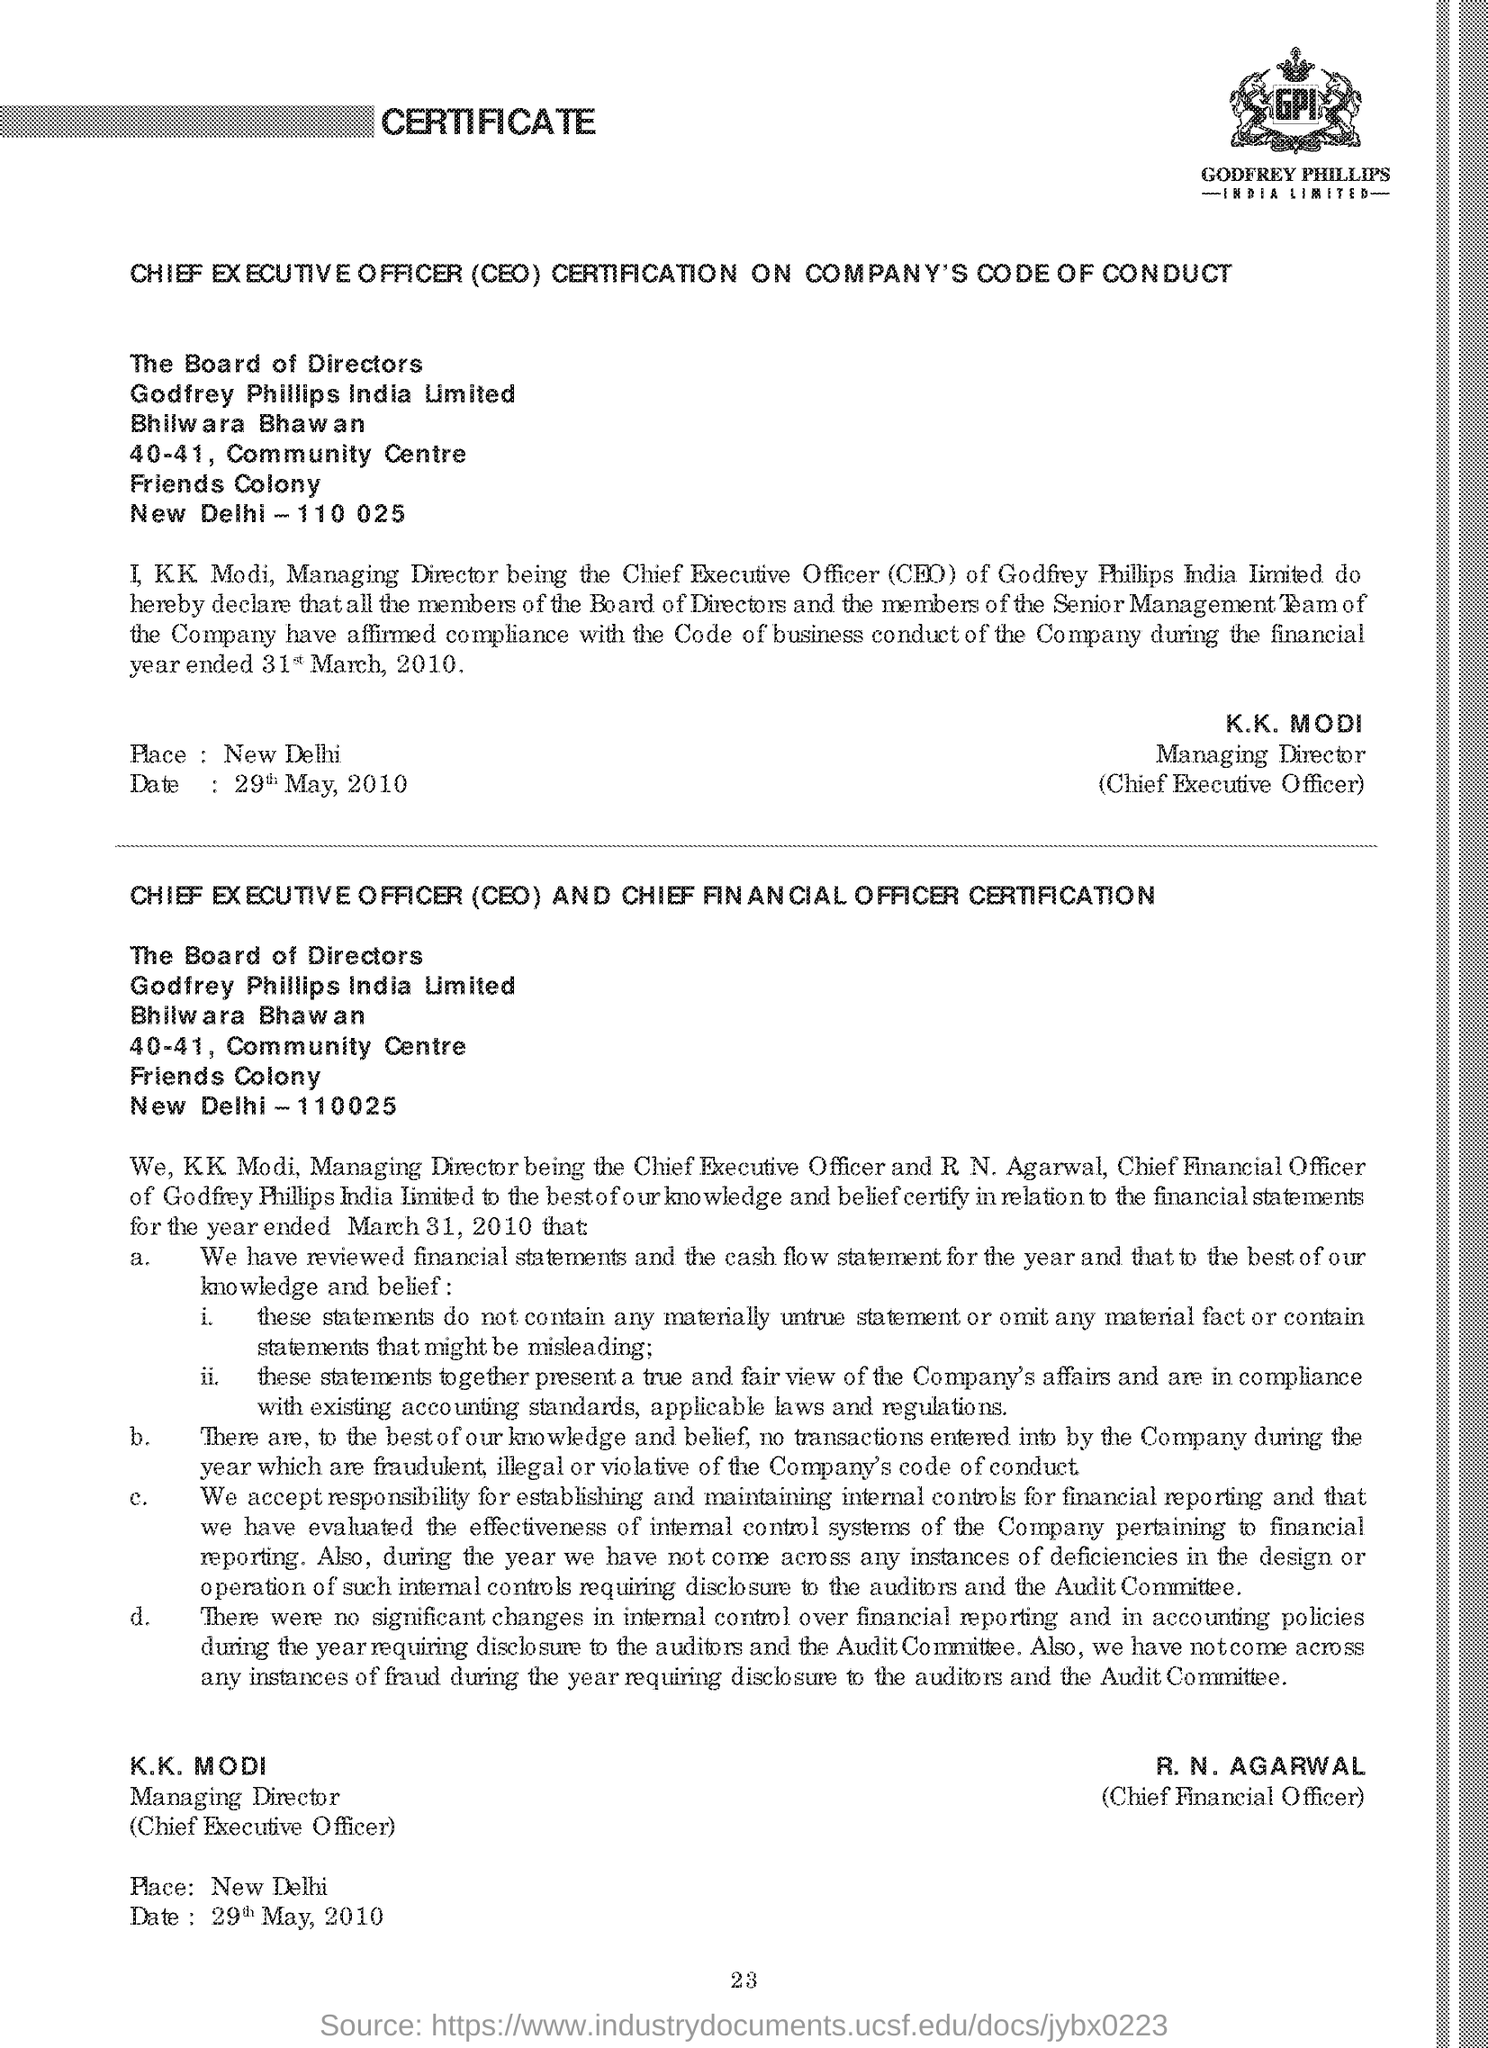Who is the managing director of the company
Your response must be concise. KK Modi. What is CEO stands for
Provide a short and direct response. Chief Executive Officer. What is the name of Chief Financial Officer
Give a very brief answer. R. N .AGARWAL. What is Witten on top of the page in bold
Your answer should be compact. CERTIFICATE. 